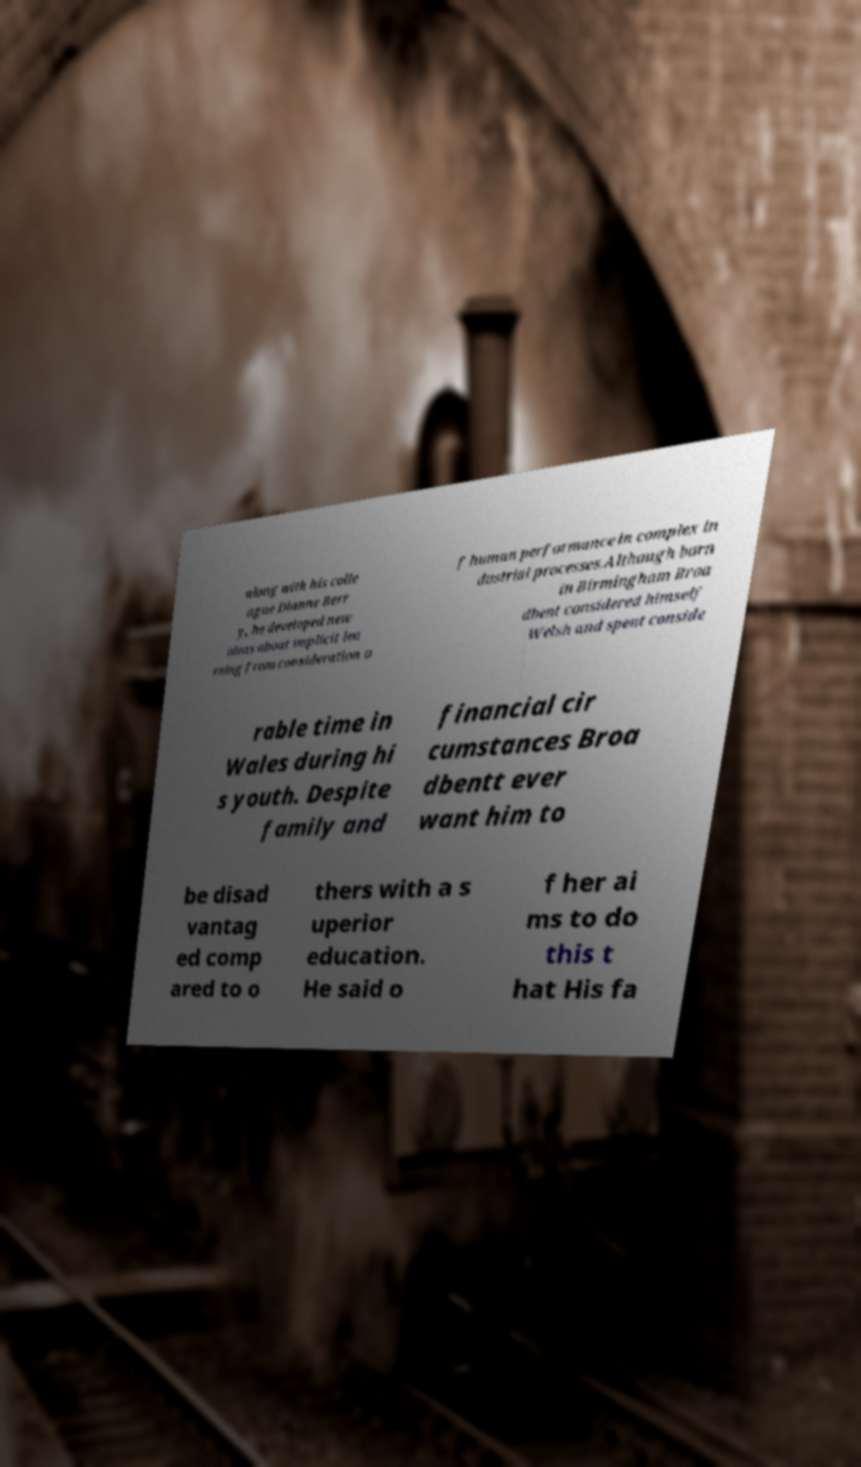There's text embedded in this image that I need extracted. Can you transcribe it verbatim? along with his colle ague Dianne Berr y, he developed new ideas about implicit lea rning from consideration o f human performance in complex in dustrial processes.Although born in Birmingham Broa dbent considered himself Welsh and spent conside rable time in Wales during hi s youth. Despite family and financial cir cumstances Broa dbentt ever want him to be disad vantag ed comp ared to o thers with a s uperior education. He said o f her ai ms to do this t hat His fa 